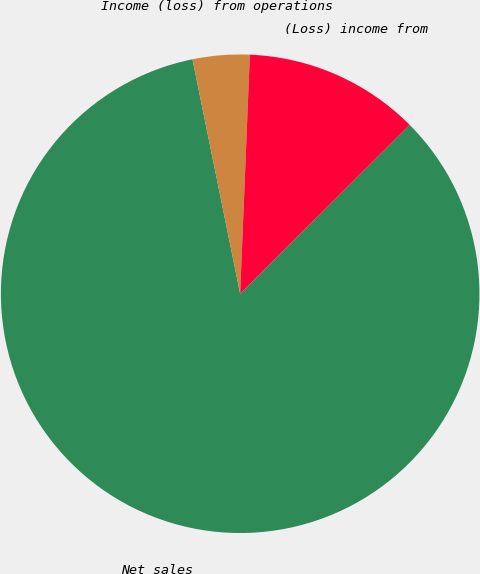<chart> <loc_0><loc_0><loc_500><loc_500><pie_chart><fcel>Net sales<fcel>Income (loss) from operations<fcel>(Loss) income from<nl><fcel>84.28%<fcel>3.84%<fcel>11.88%<nl></chart> 